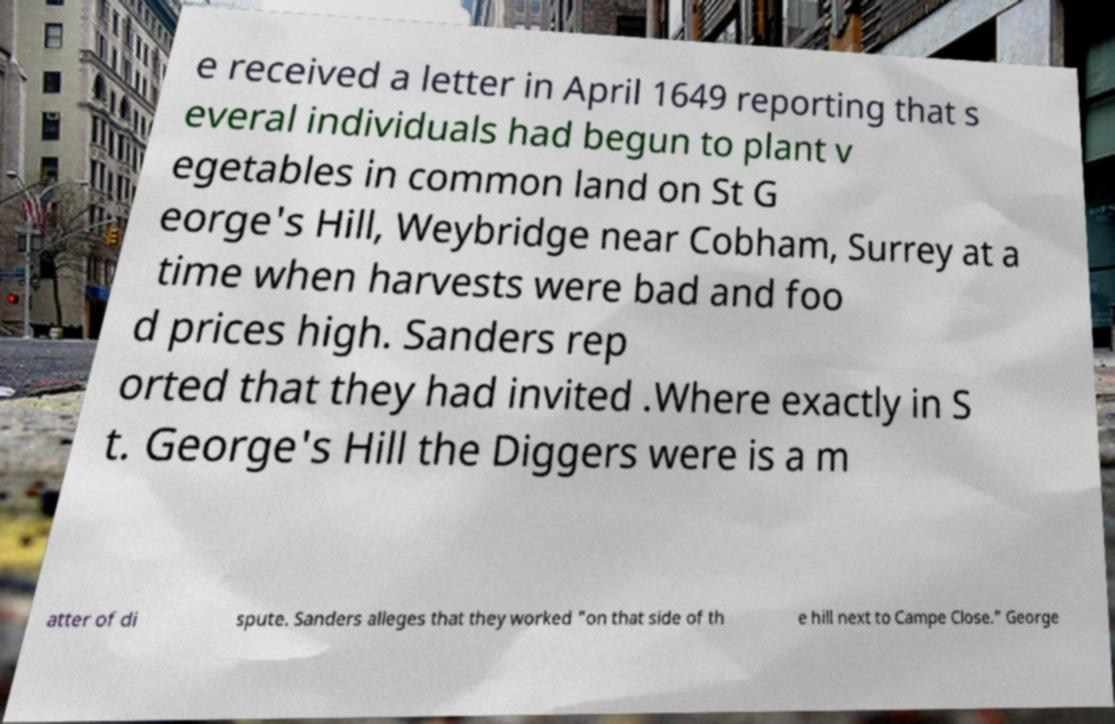Can you accurately transcribe the text from the provided image for me? e received a letter in April 1649 reporting that s everal individuals had begun to plant v egetables in common land on St G eorge's Hill, Weybridge near Cobham, Surrey at a time when harvests were bad and foo d prices high. Sanders rep orted that they had invited .Where exactly in S t. George's Hill the Diggers were is a m atter of di spute. Sanders alleges that they worked "on that side of th e hill next to Campe Close." George 